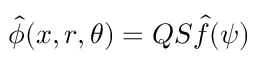Convert formula to latex. <formula><loc_0><loc_0><loc_500><loc_500>\hat { \phi } ( x , r , \theta ) = Q S \hat { f } ( \psi )</formula> 